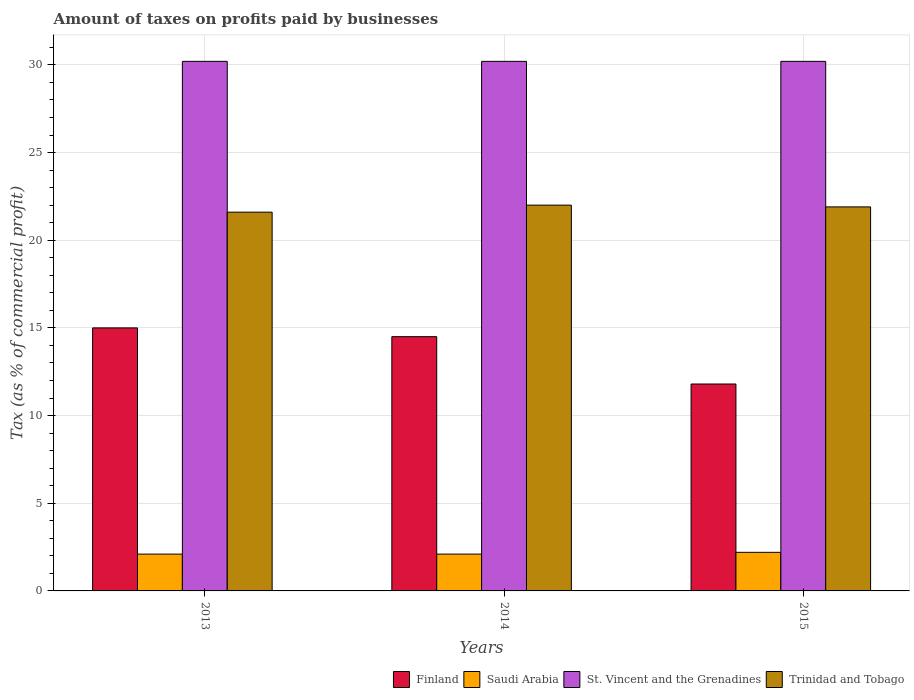How many groups of bars are there?
Offer a very short reply. 3. Are the number of bars per tick equal to the number of legend labels?
Your response must be concise. Yes. Are the number of bars on each tick of the X-axis equal?
Ensure brevity in your answer.  Yes. In how many cases, is the number of bars for a given year not equal to the number of legend labels?
Your response must be concise. 0. What is the percentage of taxes paid by businesses in Trinidad and Tobago in 2015?
Make the answer very short. 21.9. Across all years, what is the minimum percentage of taxes paid by businesses in Trinidad and Tobago?
Provide a short and direct response. 21.6. In which year was the percentage of taxes paid by businesses in Finland maximum?
Your answer should be very brief. 2013. In which year was the percentage of taxes paid by businesses in Saudi Arabia minimum?
Offer a very short reply. 2013. What is the total percentage of taxes paid by businesses in St. Vincent and the Grenadines in the graph?
Give a very brief answer. 90.6. What is the difference between the percentage of taxes paid by businesses in St. Vincent and the Grenadines in 2013 and that in 2015?
Your answer should be compact. 0. What is the difference between the percentage of taxes paid by businesses in St. Vincent and the Grenadines in 2015 and the percentage of taxes paid by businesses in Trinidad and Tobago in 2014?
Your response must be concise. 8.2. What is the average percentage of taxes paid by businesses in Saudi Arabia per year?
Your answer should be compact. 2.13. In the year 2013, what is the difference between the percentage of taxes paid by businesses in Saudi Arabia and percentage of taxes paid by businesses in St. Vincent and the Grenadines?
Make the answer very short. -28.1. In how many years, is the percentage of taxes paid by businesses in Finland greater than 30 %?
Ensure brevity in your answer.  0. Is the percentage of taxes paid by businesses in Trinidad and Tobago in 2014 less than that in 2015?
Your answer should be compact. No. Is the difference between the percentage of taxes paid by businesses in Saudi Arabia in 2014 and 2015 greater than the difference between the percentage of taxes paid by businesses in St. Vincent and the Grenadines in 2014 and 2015?
Offer a very short reply. No. What is the difference between the highest and the second highest percentage of taxes paid by businesses in Finland?
Offer a terse response. 0.5. What is the difference between the highest and the lowest percentage of taxes paid by businesses in St. Vincent and the Grenadines?
Make the answer very short. 0. What does the 4th bar from the left in 2013 represents?
Give a very brief answer. Trinidad and Tobago. What does the 4th bar from the right in 2013 represents?
Your answer should be very brief. Finland. Is it the case that in every year, the sum of the percentage of taxes paid by businesses in Finland and percentage of taxes paid by businesses in St. Vincent and the Grenadines is greater than the percentage of taxes paid by businesses in Trinidad and Tobago?
Provide a short and direct response. Yes. How many years are there in the graph?
Give a very brief answer. 3. What is the difference between two consecutive major ticks on the Y-axis?
Keep it short and to the point. 5. Are the values on the major ticks of Y-axis written in scientific E-notation?
Offer a very short reply. No. How are the legend labels stacked?
Provide a short and direct response. Horizontal. What is the title of the graph?
Your response must be concise. Amount of taxes on profits paid by businesses. What is the label or title of the X-axis?
Make the answer very short. Years. What is the label or title of the Y-axis?
Give a very brief answer. Tax (as % of commercial profit). What is the Tax (as % of commercial profit) in Finland in 2013?
Offer a very short reply. 15. What is the Tax (as % of commercial profit) of St. Vincent and the Grenadines in 2013?
Offer a very short reply. 30.2. What is the Tax (as % of commercial profit) of Trinidad and Tobago in 2013?
Keep it short and to the point. 21.6. What is the Tax (as % of commercial profit) of Finland in 2014?
Offer a terse response. 14.5. What is the Tax (as % of commercial profit) of Saudi Arabia in 2014?
Make the answer very short. 2.1. What is the Tax (as % of commercial profit) of St. Vincent and the Grenadines in 2014?
Offer a very short reply. 30.2. What is the Tax (as % of commercial profit) of Saudi Arabia in 2015?
Keep it short and to the point. 2.2. What is the Tax (as % of commercial profit) of St. Vincent and the Grenadines in 2015?
Make the answer very short. 30.2. What is the Tax (as % of commercial profit) of Trinidad and Tobago in 2015?
Keep it short and to the point. 21.9. Across all years, what is the maximum Tax (as % of commercial profit) of St. Vincent and the Grenadines?
Keep it short and to the point. 30.2. Across all years, what is the maximum Tax (as % of commercial profit) in Trinidad and Tobago?
Your response must be concise. 22. Across all years, what is the minimum Tax (as % of commercial profit) in Finland?
Ensure brevity in your answer.  11.8. Across all years, what is the minimum Tax (as % of commercial profit) in Saudi Arabia?
Keep it short and to the point. 2.1. Across all years, what is the minimum Tax (as % of commercial profit) of St. Vincent and the Grenadines?
Give a very brief answer. 30.2. Across all years, what is the minimum Tax (as % of commercial profit) in Trinidad and Tobago?
Your answer should be compact. 21.6. What is the total Tax (as % of commercial profit) of Finland in the graph?
Keep it short and to the point. 41.3. What is the total Tax (as % of commercial profit) of St. Vincent and the Grenadines in the graph?
Keep it short and to the point. 90.6. What is the total Tax (as % of commercial profit) in Trinidad and Tobago in the graph?
Make the answer very short. 65.5. What is the difference between the Tax (as % of commercial profit) in St. Vincent and the Grenadines in 2013 and that in 2014?
Offer a terse response. 0. What is the difference between the Tax (as % of commercial profit) in Finland in 2013 and that in 2015?
Offer a very short reply. 3.2. What is the difference between the Tax (as % of commercial profit) of Saudi Arabia in 2013 and that in 2015?
Keep it short and to the point. -0.1. What is the difference between the Tax (as % of commercial profit) of St. Vincent and the Grenadines in 2013 and that in 2015?
Provide a short and direct response. 0. What is the difference between the Tax (as % of commercial profit) in Saudi Arabia in 2014 and that in 2015?
Provide a short and direct response. -0.1. What is the difference between the Tax (as % of commercial profit) in Trinidad and Tobago in 2014 and that in 2015?
Make the answer very short. 0.1. What is the difference between the Tax (as % of commercial profit) in Finland in 2013 and the Tax (as % of commercial profit) in St. Vincent and the Grenadines in 2014?
Offer a terse response. -15.2. What is the difference between the Tax (as % of commercial profit) of Saudi Arabia in 2013 and the Tax (as % of commercial profit) of St. Vincent and the Grenadines in 2014?
Give a very brief answer. -28.1. What is the difference between the Tax (as % of commercial profit) of Saudi Arabia in 2013 and the Tax (as % of commercial profit) of Trinidad and Tobago in 2014?
Your answer should be compact. -19.9. What is the difference between the Tax (as % of commercial profit) of St. Vincent and the Grenadines in 2013 and the Tax (as % of commercial profit) of Trinidad and Tobago in 2014?
Make the answer very short. 8.2. What is the difference between the Tax (as % of commercial profit) of Finland in 2013 and the Tax (as % of commercial profit) of St. Vincent and the Grenadines in 2015?
Your response must be concise. -15.2. What is the difference between the Tax (as % of commercial profit) in Saudi Arabia in 2013 and the Tax (as % of commercial profit) in St. Vincent and the Grenadines in 2015?
Your answer should be very brief. -28.1. What is the difference between the Tax (as % of commercial profit) in Saudi Arabia in 2013 and the Tax (as % of commercial profit) in Trinidad and Tobago in 2015?
Your answer should be very brief. -19.8. What is the difference between the Tax (as % of commercial profit) of St. Vincent and the Grenadines in 2013 and the Tax (as % of commercial profit) of Trinidad and Tobago in 2015?
Ensure brevity in your answer.  8.3. What is the difference between the Tax (as % of commercial profit) in Finland in 2014 and the Tax (as % of commercial profit) in St. Vincent and the Grenadines in 2015?
Give a very brief answer. -15.7. What is the difference between the Tax (as % of commercial profit) in Finland in 2014 and the Tax (as % of commercial profit) in Trinidad and Tobago in 2015?
Make the answer very short. -7.4. What is the difference between the Tax (as % of commercial profit) of Saudi Arabia in 2014 and the Tax (as % of commercial profit) of St. Vincent and the Grenadines in 2015?
Ensure brevity in your answer.  -28.1. What is the difference between the Tax (as % of commercial profit) of Saudi Arabia in 2014 and the Tax (as % of commercial profit) of Trinidad and Tobago in 2015?
Offer a very short reply. -19.8. What is the difference between the Tax (as % of commercial profit) of St. Vincent and the Grenadines in 2014 and the Tax (as % of commercial profit) of Trinidad and Tobago in 2015?
Make the answer very short. 8.3. What is the average Tax (as % of commercial profit) of Finland per year?
Make the answer very short. 13.77. What is the average Tax (as % of commercial profit) in Saudi Arabia per year?
Your answer should be very brief. 2.13. What is the average Tax (as % of commercial profit) in St. Vincent and the Grenadines per year?
Your answer should be very brief. 30.2. What is the average Tax (as % of commercial profit) in Trinidad and Tobago per year?
Offer a terse response. 21.83. In the year 2013, what is the difference between the Tax (as % of commercial profit) of Finland and Tax (as % of commercial profit) of St. Vincent and the Grenadines?
Offer a terse response. -15.2. In the year 2013, what is the difference between the Tax (as % of commercial profit) in Finland and Tax (as % of commercial profit) in Trinidad and Tobago?
Provide a succinct answer. -6.6. In the year 2013, what is the difference between the Tax (as % of commercial profit) of Saudi Arabia and Tax (as % of commercial profit) of St. Vincent and the Grenadines?
Offer a very short reply. -28.1. In the year 2013, what is the difference between the Tax (as % of commercial profit) in Saudi Arabia and Tax (as % of commercial profit) in Trinidad and Tobago?
Offer a terse response. -19.5. In the year 2013, what is the difference between the Tax (as % of commercial profit) in St. Vincent and the Grenadines and Tax (as % of commercial profit) in Trinidad and Tobago?
Provide a short and direct response. 8.6. In the year 2014, what is the difference between the Tax (as % of commercial profit) in Finland and Tax (as % of commercial profit) in St. Vincent and the Grenadines?
Your answer should be compact. -15.7. In the year 2014, what is the difference between the Tax (as % of commercial profit) in Finland and Tax (as % of commercial profit) in Trinidad and Tobago?
Your answer should be very brief. -7.5. In the year 2014, what is the difference between the Tax (as % of commercial profit) of Saudi Arabia and Tax (as % of commercial profit) of St. Vincent and the Grenadines?
Give a very brief answer. -28.1. In the year 2014, what is the difference between the Tax (as % of commercial profit) of Saudi Arabia and Tax (as % of commercial profit) of Trinidad and Tobago?
Give a very brief answer. -19.9. In the year 2015, what is the difference between the Tax (as % of commercial profit) of Finland and Tax (as % of commercial profit) of St. Vincent and the Grenadines?
Offer a terse response. -18.4. In the year 2015, what is the difference between the Tax (as % of commercial profit) of Saudi Arabia and Tax (as % of commercial profit) of Trinidad and Tobago?
Offer a very short reply. -19.7. In the year 2015, what is the difference between the Tax (as % of commercial profit) in St. Vincent and the Grenadines and Tax (as % of commercial profit) in Trinidad and Tobago?
Ensure brevity in your answer.  8.3. What is the ratio of the Tax (as % of commercial profit) in Finland in 2013 to that in 2014?
Ensure brevity in your answer.  1.03. What is the ratio of the Tax (as % of commercial profit) of Trinidad and Tobago in 2013 to that in 2014?
Ensure brevity in your answer.  0.98. What is the ratio of the Tax (as % of commercial profit) in Finland in 2013 to that in 2015?
Offer a very short reply. 1.27. What is the ratio of the Tax (as % of commercial profit) in Saudi Arabia in 2013 to that in 2015?
Give a very brief answer. 0.95. What is the ratio of the Tax (as % of commercial profit) of St. Vincent and the Grenadines in 2013 to that in 2015?
Ensure brevity in your answer.  1. What is the ratio of the Tax (as % of commercial profit) in Trinidad and Tobago in 2013 to that in 2015?
Give a very brief answer. 0.99. What is the ratio of the Tax (as % of commercial profit) in Finland in 2014 to that in 2015?
Keep it short and to the point. 1.23. What is the ratio of the Tax (as % of commercial profit) in Saudi Arabia in 2014 to that in 2015?
Keep it short and to the point. 0.95. What is the ratio of the Tax (as % of commercial profit) in St. Vincent and the Grenadines in 2014 to that in 2015?
Keep it short and to the point. 1. What is the ratio of the Tax (as % of commercial profit) of Trinidad and Tobago in 2014 to that in 2015?
Keep it short and to the point. 1. What is the difference between the highest and the second highest Tax (as % of commercial profit) in Finland?
Your answer should be compact. 0.5. What is the difference between the highest and the second highest Tax (as % of commercial profit) of Saudi Arabia?
Ensure brevity in your answer.  0.1. What is the difference between the highest and the second highest Tax (as % of commercial profit) of St. Vincent and the Grenadines?
Make the answer very short. 0. What is the difference between the highest and the lowest Tax (as % of commercial profit) of Finland?
Offer a very short reply. 3.2. What is the difference between the highest and the lowest Tax (as % of commercial profit) in St. Vincent and the Grenadines?
Ensure brevity in your answer.  0. What is the difference between the highest and the lowest Tax (as % of commercial profit) of Trinidad and Tobago?
Keep it short and to the point. 0.4. 